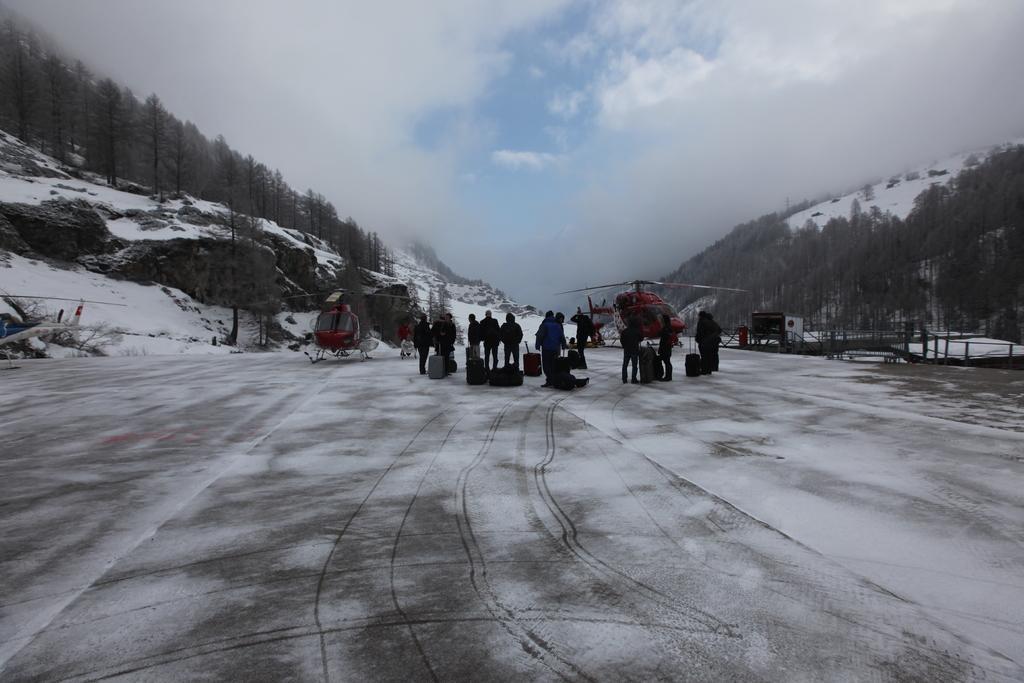Can you describe this image briefly? This image is taken outdoors. At the top of the image there is a sky with clouds. At the bottom of the image there is a road. In the background there are a few hills covered with snow. There are many trees with leaves, stems and branches. There are a few rocks. In the middle of the image a few people are standing on the road and there are a few luggage bags on the road. On the right side of the image there are a few wooden sticks. In the middle of the image there is a chopper on the road. 